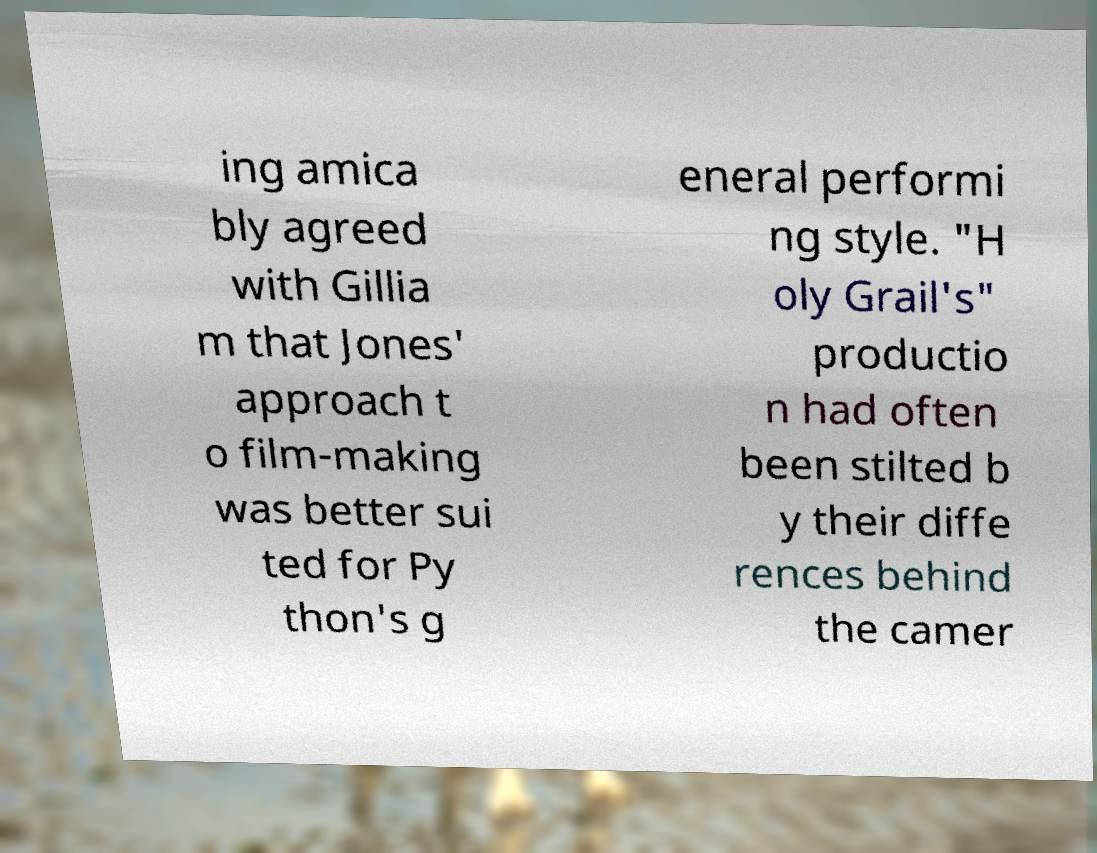What messages or text are displayed in this image? I need them in a readable, typed format. ing amica bly agreed with Gillia m that Jones' approach t o film-making was better sui ted for Py thon's g eneral performi ng style. "H oly Grail's" productio n had often been stilted b y their diffe rences behind the camer 